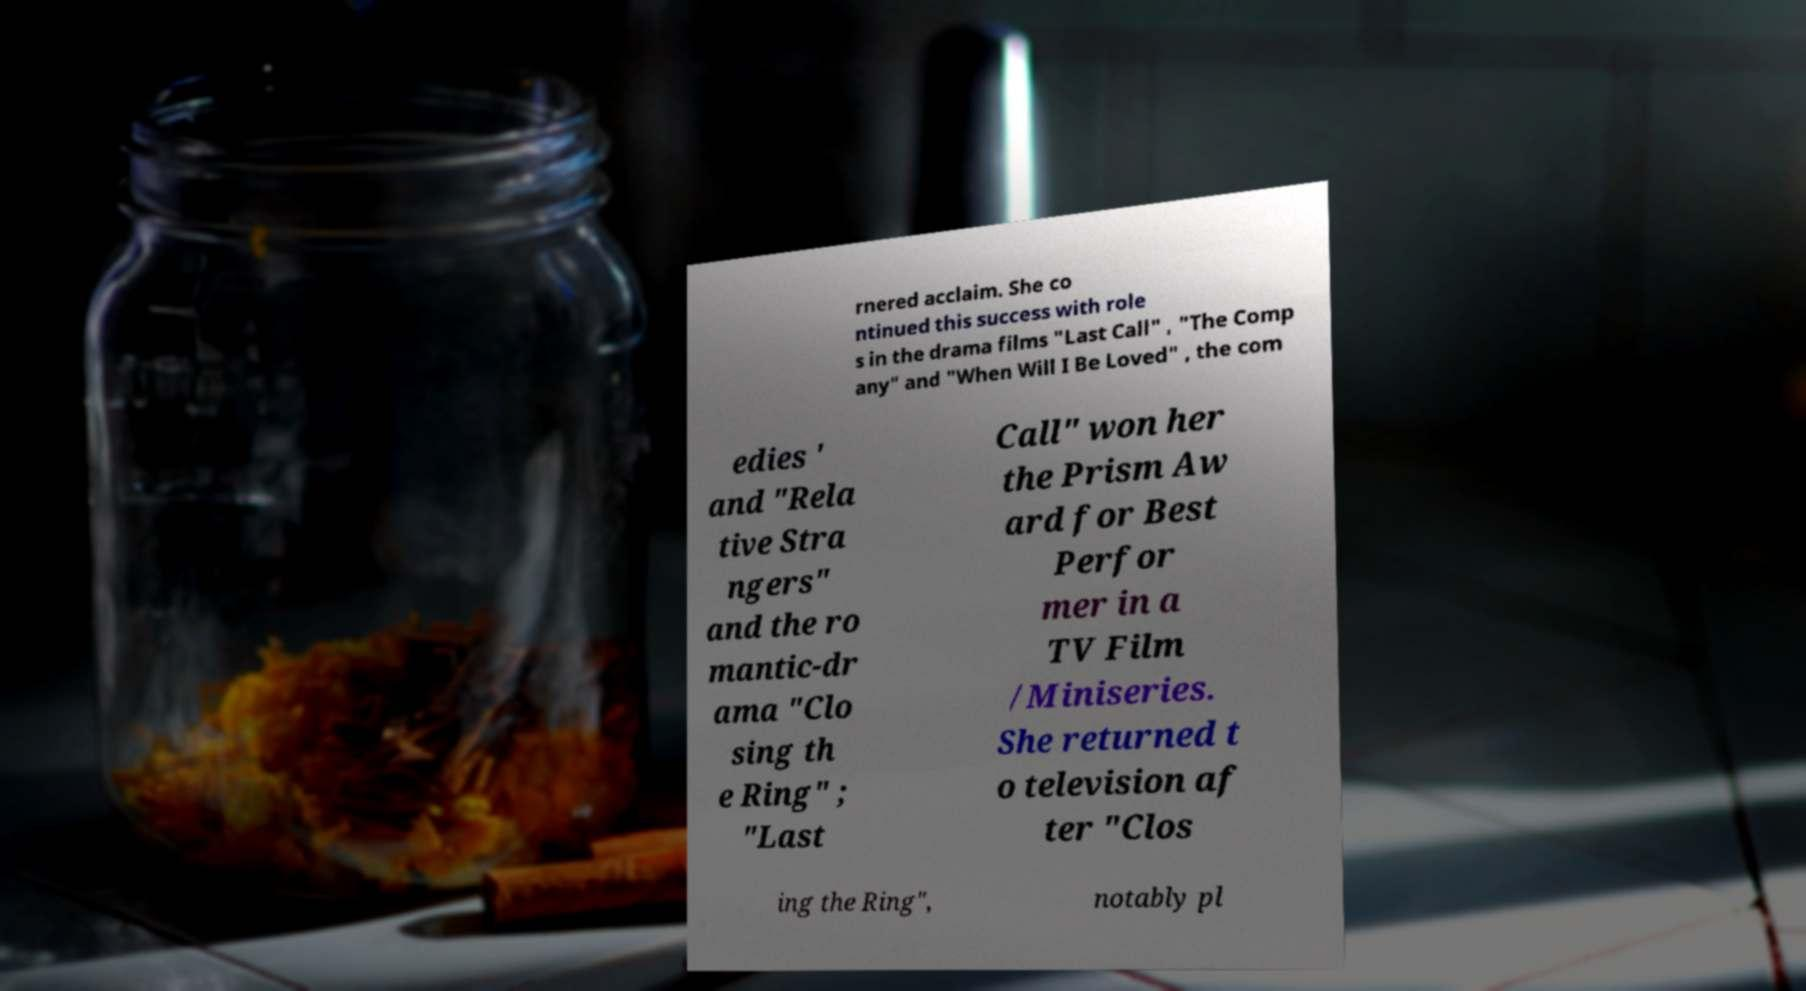Please identify and transcribe the text found in this image. rnered acclaim. She co ntinued this success with role s in the drama films "Last Call" , "The Comp any" and "When Will I Be Loved" , the com edies ' and "Rela tive Stra ngers" and the ro mantic-dr ama "Clo sing th e Ring" ; "Last Call" won her the Prism Aw ard for Best Perfor mer in a TV Film /Miniseries. She returned t o television af ter "Clos ing the Ring", notably pl 